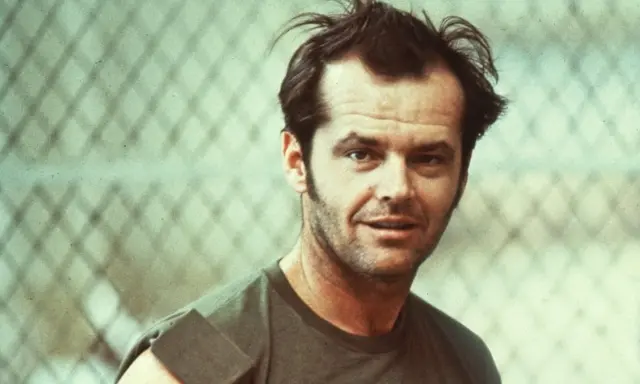Can you describe the main features of this image for me? This image depicts a young man standing in front of a chain-link fence. He is wearing a green tank top and has slightly disheveled hair, giving him a casual and relaxed appearance. His facial expression is serious and introspective, adding a sense of depth and intensity to his demeanor. The overall color palette of the photograph is faded, enhancing its vintage, retro aesthetic. 